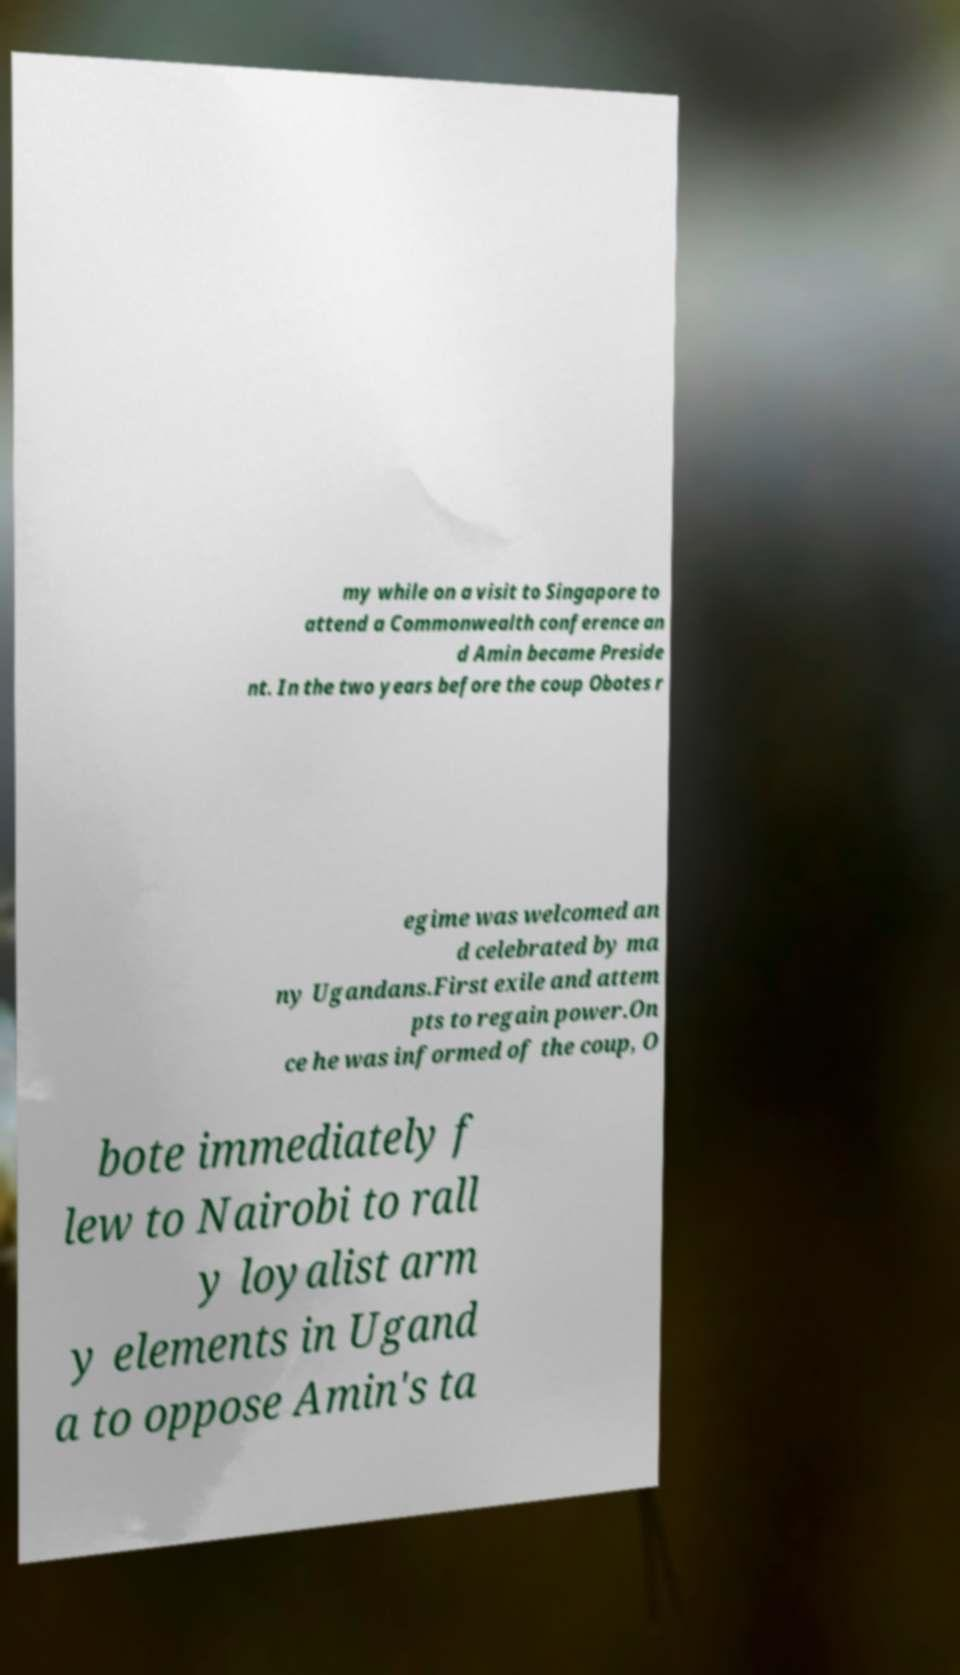I need the written content from this picture converted into text. Can you do that? my while on a visit to Singapore to attend a Commonwealth conference an d Amin became Preside nt. In the two years before the coup Obotes r egime was welcomed an d celebrated by ma ny Ugandans.First exile and attem pts to regain power.On ce he was informed of the coup, O bote immediately f lew to Nairobi to rall y loyalist arm y elements in Ugand a to oppose Amin's ta 